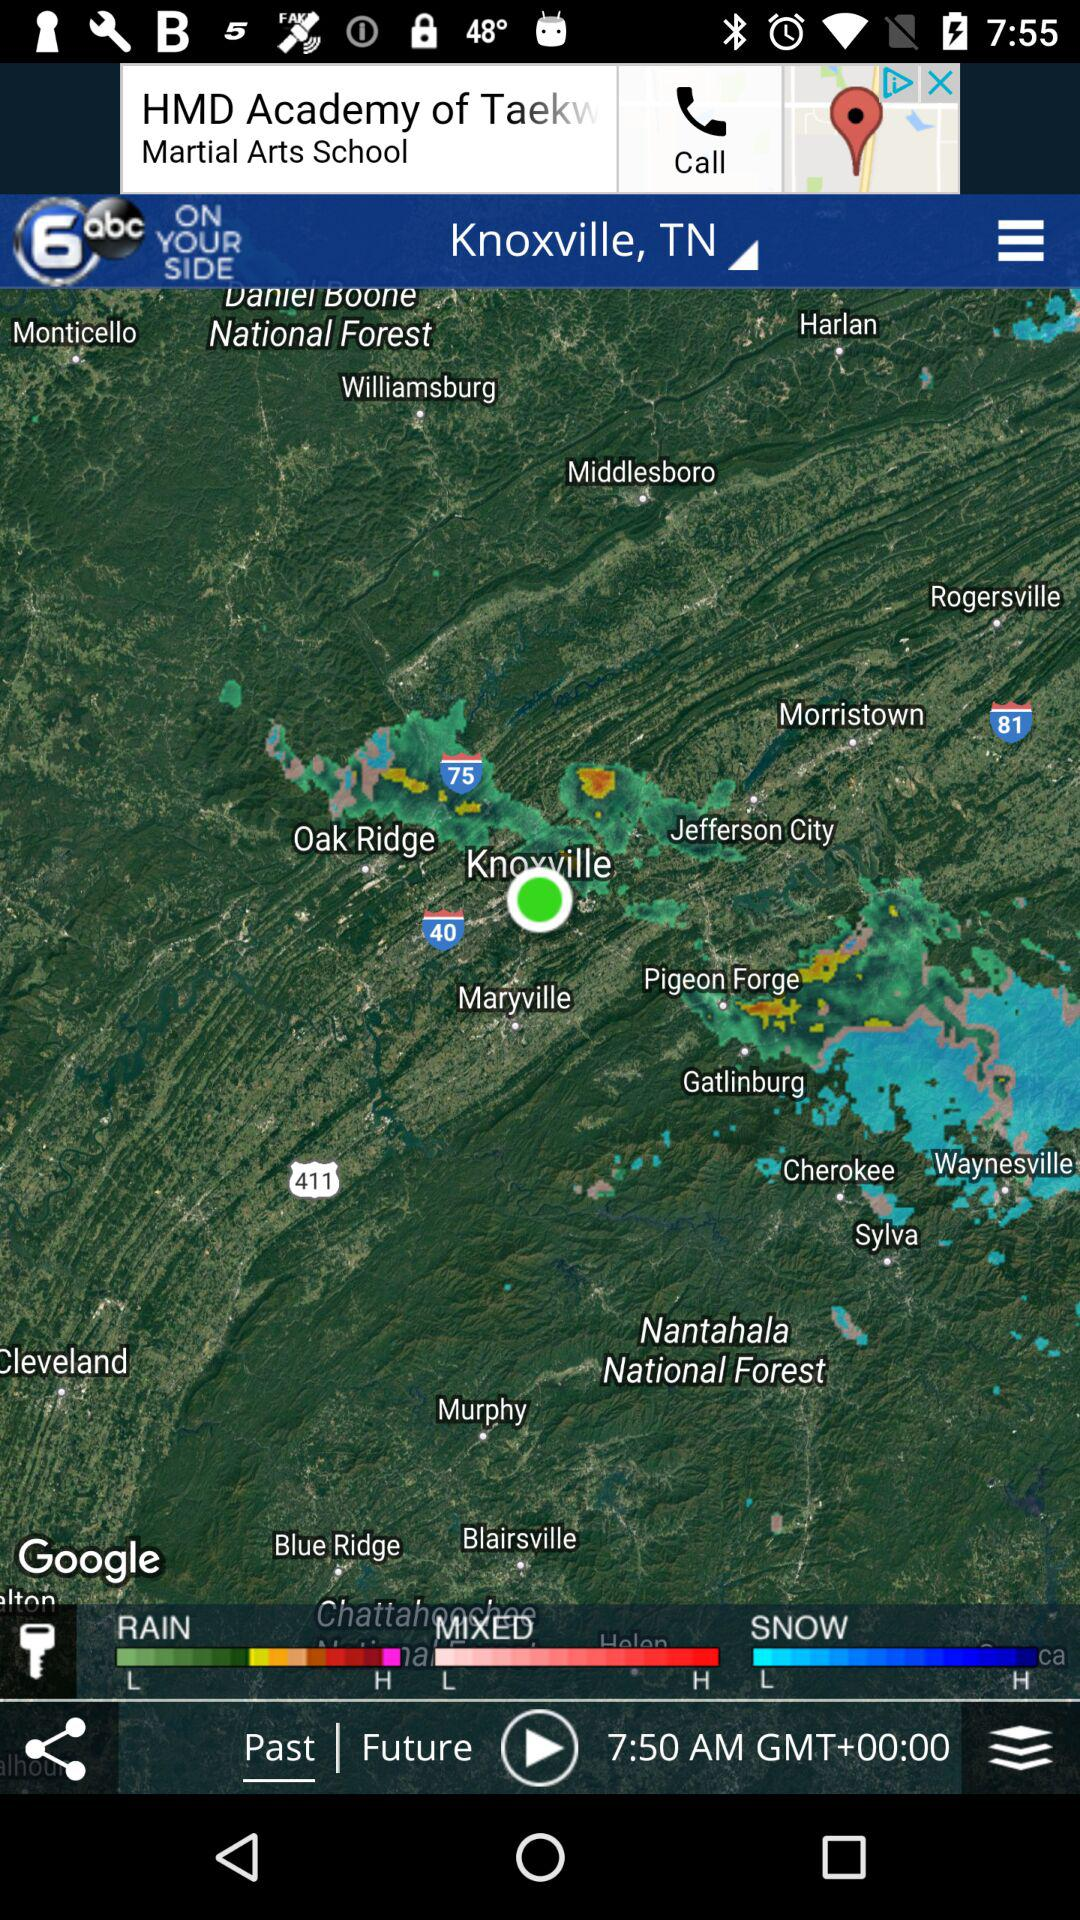How many hours ahead of UTC is the location?
Answer the question using a single word or phrase. 0 